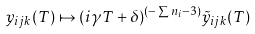Convert formula to latex. <formula><loc_0><loc_0><loc_500><loc_500>y _ { i j k } ( T ) \mapsto ( i \gamma T + \delta ) ^ { ( - \sum n _ { i } - 3 ) } \tilde { y } _ { i j k } ( T )</formula> 